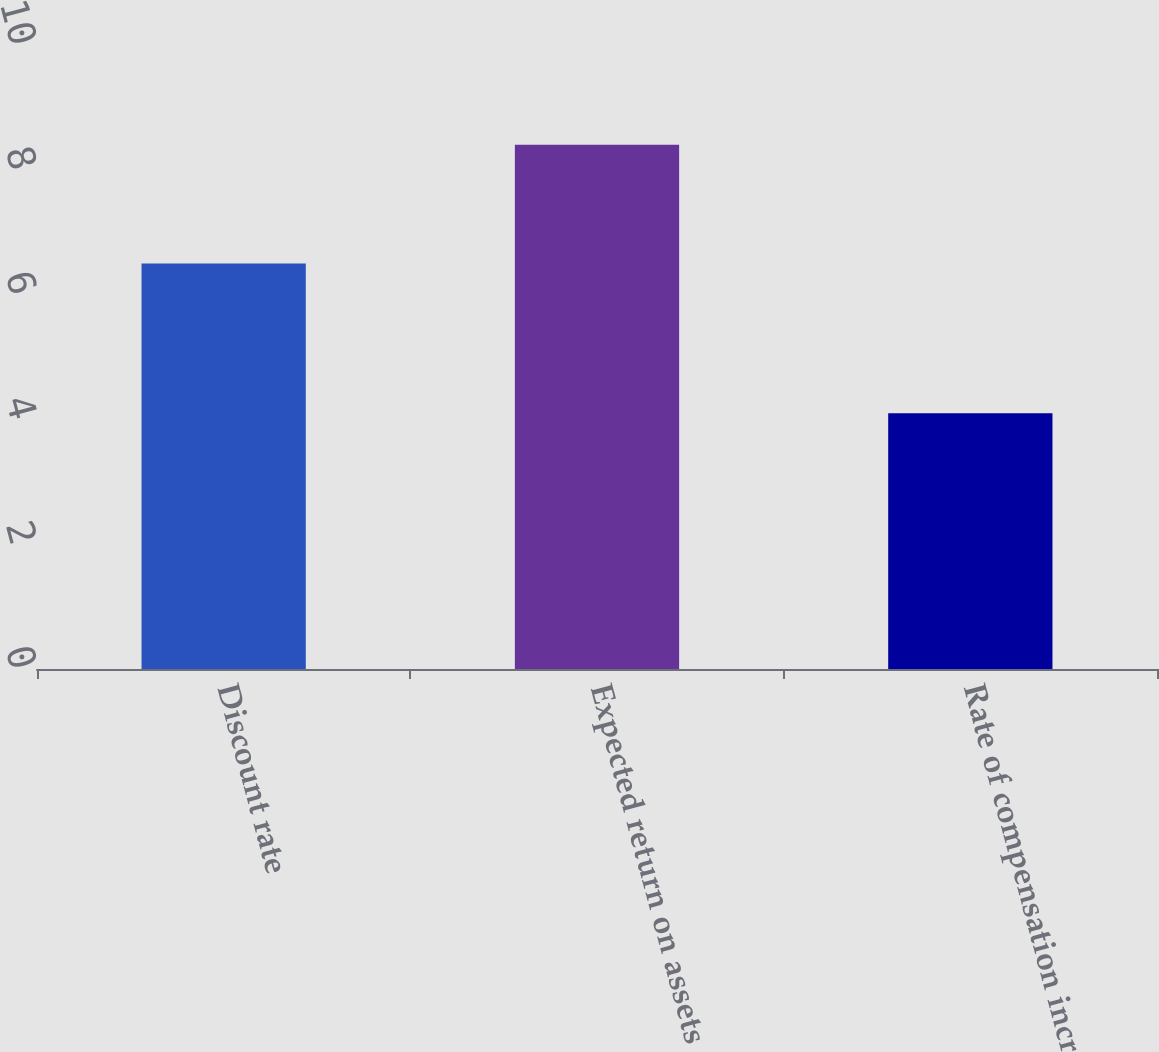Convert chart to OTSL. <chart><loc_0><loc_0><loc_500><loc_500><bar_chart><fcel>Discount rate<fcel>Expected return on assets<fcel>Rate of compensation increase<nl><fcel>6.5<fcel>8.4<fcel>4.1<nl></chart> 